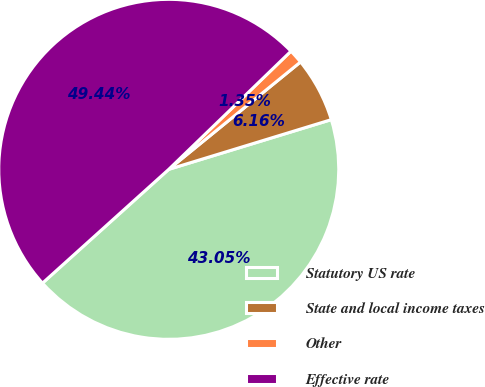Convert chart to OTSL. <chart><loc_0><loc_0><loc_500><loc_500><pie_chart><fcel>Statutory US rate<fcel>State and local income taxes<fcel>Other<fcel>Effective rate<nl><fcel>43.05%<fcel>6.16%<fcel>1.35%<fcel>49.44%<nl></chart> 